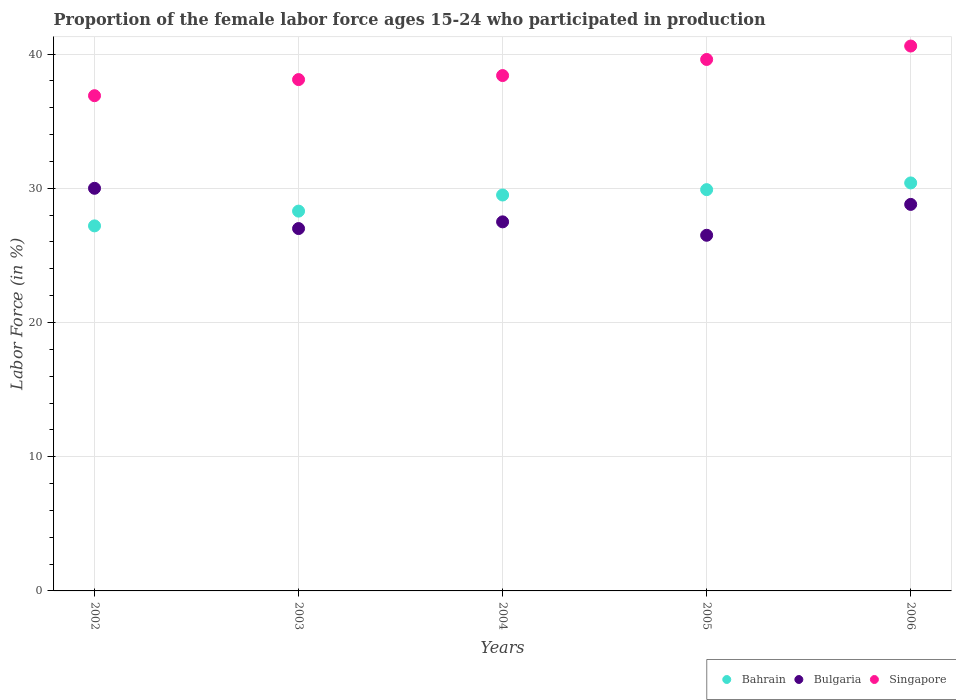Is the number of dotlines equal to the number of legend labels?
Offer a terse response. Yes. What is the proportion of the female labor force who participated in production in Singapore in 2004?
Your response must be concise. 38.4. What is the total proportion of the female labor force who participated in production in Bahrain in the graph?
Your answer should be compact. 145.3. What is the difference between the proportion of the female labor force who participated in production in Bulgaria in 2002 and that in 2005?
Offer a terse response. 3.5. What is the difference between the proportion of the female labor force who participated in production in Bulgaria in 2004 and the proportion of the female labor force who participated in production in Singapore in 2005?
Your answer should be very brief. -12.1. What is the average proportion of the female labor force who participated in production in Bahrain per year?
Keep it short and to the point. 29.06. In the year 2004, what is the difference between the proportion of the female labor force who participated in production in Bahrain and proportion of the female labor force who participated in production in Singapore?
Your answer should be compact. -8.9. What is the ratio of the proportion of the female labor force who participated in production in Bahrain in 2005 to that in 2006?
Provide a succinct answer. 0.98. Is the proportion of the female labor force who participated in production in Bulgaria in 2003 less than that in 2005?
Your answer should be very brief. No. Is the difference between the proportion of the female labor force who participated in production in Bahrain in 2002 and 2006 greater than the difference between the proportion of the female labor force who participated in production in Singapore in 2002 and 2006?
Make the answer very short. Yes. What is the difference between the highest and the second highest proportion of the female labor force who participated in production in Bahrain?
Provide a succinct answer. 0.5. What is the difference between the highest and the lowest proportion of the female labor force who participated in production in Bahrain?
Your answer should be compact. 3.2. In how many years, is the proportion of the female labor force who participated in production in Bahrain greater than the average proportion of the female labor force who participated in production in Bahrain taken over all years?
Offer a very short reply. 3. Is it the case that in every year, the sum of the proportion of the female labor force who participated in production in Bahrain and proportion of the female labor force who participated in production in Bulgaria  is greater than the proportion of the female labor force who participated in production in Singapore?
Your answer should be very brief. Yes. Does the proportion of the female labor force who participated in production in Singapore monotonically increase over the years?
Offer a terse response. Yes. How many years are there in the graph?
Your response must be concise. 5. Are the values on the major ticks of Y-axis written in scientific E-notation?
Offer a terse response. No. Does the graph contain any zero values?
Your answer should be compact. No. Where does the legend appear in the graph?
Provide a short and direct response. Bottom right. What is the title of the graph?
Provide a succinct answer. Proportion of the female labor force ages 15-24 who participated in production. Does "Suriname" appear as one of the legend labels in the graph?
Your answer should be compact. No. What is the label or title of the X-axis?
Ensure brevity in your answer.  Years. What is the Labor Force (in %) of Bahrain in 2002?
Provide a short and direct response. 27.2. What is the Labor Force (in %) of Singapore in 2002?
Your answer should be very brief. 36.9. What is the Labor Force (in %) of Bahrain in 2003?
Offer a very short reply. 28.3. What is the Labor Force (in %) of Bulgaria in 2003?
Provide a succinct answer. 27. What is the Labor Force (in %) of Singapore in 2003?
Your answer should be very brief. 38.1. What is the Labor Force (in %) in Bahrain in 2004?
Make the answer very short. 29.5. What is the Labor Force (in %) in Bulgaria in 2004?
Your answer should be very brief. 27.5. What is the Labor Force (in %) of Singapore in 2004?
Give a very brief answer. 38.4. What is the Labor Force (in %) in Bahrain in 2005?
Provide a short and direct response. 29.9. What is the Labor Force (in %) in Bulgaria in 2005?
Ensure brevity in your answer.  26.5. What is the Labor Force (in %) in Singapore in 2005?
Offer a terse response. 39.6. What is the Labor Force (in %) in Bahrain in 2006?
Your answer should be very brief. 30.4. What is the Labor Force (in %) in Bulgaria in 2006?
Provide a short and direct response. 28.8. What is the Labor Force (in %) in Singapore in 2006?
Keep it short and to the point. 40.6. Across all years, what is the maximum Labor Force (in %) in Bahrain?
Make the answer very short. 30.4. Across all years, what is the maximum Labor Force (in %) in Bulgaria?
Offer a terse response. 30. Across all years, what is the maximum Labor Force (in %) of Singapore?
Your answer should be very brief. 40.6. Across all years, what is the minimum Labor Force (in %) of Bahrain?
Make the answer very short. 27.2. Across all years, what is the minimum Labor Force (in %) of Singapore?
Offer a very short reply. 36.9. What is the total Labor Force (in %) of Bahrain in the graph?
Offer a terse response. 145.3. What is the total Labor Force (in %) in Bulgaria in the graph?
Offer a terse response. 139.8. What is the total Labor Force (in %) of Singapore in the graph?
Your response must be concise. 193.6. What is the difference between the Labor Force (in %) of Bahrain in 2002 and that in 2003?
Your response must be concise. -1.1. What is the difference between the Labor Force (in %) of Singapore in 2002 and that in 2003?
Give a very brief answer. -1.2. What is the difference between the Labor Force (in %) of Bahrain in 2002 and that in 2004?
Offer a very short reply. -2.3. What is the difference between the Labor Force (in %) in Bulgaria in 2002 and that in 2004?
Offer a terse response. 2.5. What is the difference between the Labor Force (in %) of Singapore in 2002 and that in 2004?
Offer a terse response. -1.5. What is the difference between the Labor Force (in %) in Bahrain in 2002 and that in 2005?
Give a very brief answer. -2.7. What is the difference between the Labor Force (in %) of Bulgaria in 2002 and that in 2005?
Give a very brief answer. 3.5. What is the difference between the Labor Force (in %) in Bulgaria in 2002 and that in 2006?
Make the answer very short. 1.2. What is the difference between the Labor Force (in %) in Bulgaria in 2003 and that in 2004?
Keep it short and to the point. -0.5. What is the difference between the Labor Force (in %) in Bahrain in 2003 and that in 2005?
Offer a very short reply. -1.6. What is the difference between the Labor Force (in %) of Bahrain in 2003 and that in 2006?
Ensure brevity in your answer.  -2.1. What is the difference between the Labor Force (in %) of Bulgaria in 2003 and that in 2006?
Make the answer very short. -1.8. What is the difference between the Labor Force (in %) of Singapore in 2003 and that in 2006?
Your answer should be very brief. -2.5. What is the difference between the Labor Force (in %) in Bahrain in 2004 and that in 2005?
Provide a short and direct response. -0.4. What is the difference between the Labor Force (in %) in Singapore in 2004 and that in 2005?
Offer a very short reply. -1.2. What is the difference between the Labor Force (in %) in Bulgaria in 2004 and that in 2006?
Make the answer very short. -1.3. What is the difference between the Labor Force (in %) of Singapore in 2004 and that in 2006?
Give a very brief answer. -2.2. What is the difference between the Labor Force (in %) in Bahrain in 2005 and that in 2006?
Ensure brevity in your answer.  -0.5. What is the difference between the Labor Force (in %) of Bahrain in 2002 and the Labor Force (in %) of Bulgaria in 2004?
Your answer should be compact. -0.3. What is the difference between the Labor Force (in %) in Bahrain in 2002 and the Labor Force (in %) in Singapore in 2004?
Ensure brevity in your answer.  -11.2. What is the difference between the Labor Force (in %) of Bahrain in 2002 and the Labor Force (in %) of Bulgaria in 2005?
Give a very brief answer. 0.7. What is the difference between the Labor Force (in %) of Bahrain in 2002 and the Labor Force (in %) of Singapore in 2005?
Offer a terse response. -12.4. What is the difference between the Labor Force (in %) of Bulgaria in 2002 and the Labor Force (in %) of Singapore in 2006?
Your response must be concise. -10.6. What is the difference between the Labor Force (in %) of Bahrain in 2003 and the Labor Force (in %) of Bulgaria in 2004?
Offer a very short reply. 0.8. What is the difference between the Labor Force (in %) in Bulgaria in 2003 and the Labor Force (in %) in Singapore in 2006?
Your answer should be compact. -13.6. What is the difference between the Labor Force (in %) in Bahrain in 2004 and the Labor Force (in %) in Bulgaria in 2006?
Your response must be concise. 0.7. What is the difference between the Labor Force (in %) in Bahrain in 2005 and the Labor Force (in %) in Singapore in 2006?
Ensure brevity in your answer.  -10.7. What is the difference between the Labor Force (in %) of Bulgaria in 2005 and the Labor Force (in %) of Singapore in 2006?
Your answer should be compact. -14.1. What is the average Labor Force (in %) of Bahrain per year?
Provide a succinct answer. 29.06. What is the average Labor Force (in %) in Bulgaria per year?
Offer a very short reply. 27.96. What is the average Labor Force (in %) of Singapore per year?
Make the answer very short. 38.72. In the year 2002, what is the difference between the Labor Force (in %) in Bahrain and Labor Force (in %) in Singapore?
Your answer should be very brief. -9.7. In the year 2003, what is the difference between the Labor Force (in %) in Bahrain and Labor Force (in %) in Bulgaria?
Your answer should be very brief. 1.3. In the year 2004, what is the difference between the Labor Force (in %) of Bahrain and Labor Force (in %) of Bulgaria?
Your answer should be very brief. 2. In the year 2004, what is the difference between the Labor Force (in %) of Bulgaria and Labor Force (in %) of Singapore?
Provide a succinct answer. -10.9. In the year 2005, what is the difference between the Labor Force (in %) of Bahrain and Labor Force (in %) of Singapore?
Give a very brief answer. -9.7. In the year 2006, what is the difference between the Labor Force (in %) of Bulgaria and Labor Force (in %) of Singapore?
Give a very brief answer. -11.8. What is the ratio of the Labor Force (in %) of Bahrain in 2002 to that in 2003?
Offer a terse response. 0.96. What is the ratio of the Labor Force (in %) in Bulgaria in 2002 to that in 2003?
Your answer should be very brief. 1.11. What is the ratio of the Labor Force (in %) of Singapore in 2002 to that in 2003?
Your response must be concise. 0.97. What is the ratio of the Labor Force (in %) of Bahrain in 2002 to that in 2004?
Offer a very short reply. 0.92. What is the ratio of the Labor Force (in %) of Singapore in 2002 to that in 2004?
Your response must be concise. 0.96. What is the ratio of the Labor Force (in %) in Bahrain in 2002 to that in 2005?
Make the answer very short. 0.91. What is the ratio of the Labor Force (in %) in Bulgaria in 2002 to that in 2005?
Your answer should be very brief. 1.13. What is the ratio of the Labor Force (in %) in Singapore in 2002 to that in 2005?
Your answer should be very brief. 0.93. What is the ratio of the Labor Force (in %) of Bahrain in 2002 to that in 2006?
Provide a short and direct response. 0.89. What is the ratio of the Labor Force (in %) in Bulgaria in 2002 to that in 2006?
Offer a terse response. 1.04. What is the ratio of the Labor Force (in %) in Singapore in 2002 to that in 2006?
Provide a succinct answer. 0.91. What is the ratio of the Labor Force (in %) of Bahrain in 2003 to that in 2004?
Give a very brief answer. 0.96. What is the ratio of the Labor Force (in %) in Bulgaria in 2003 to that in 2004?
Your answer should be very brief. 0.98. What is the ratio of the Labor Force (in %) in Singapore in 2003 to that in 2004?
Keep it short and to the point. 0.99. What is the ratio of the Labor Force (in %) in Bahrain in 2003 to that in 2005?
Offer a terse response. 0.95. What is the ratio of the Labor Force (in %) in Bulgaria in 2003 to that in 2005?
Offer a very short reply. 1.02. What is the ratio of the Labor Force (in %) of Singapore in 2003 to that in 2005?
Keep it short and to the point. 0.96. What is the ratio of the Labor Force (in %) of Bahrain in 2003 to that in 2006?
Ensure brevity in your answer.  0.93. What is the ratio of the Labor Force (in %) of Singapore in 2003 to that in 2006?
Ensure brevity in your answer.  0.94. What is the ratio of the Labor Force (in %) of Bahrain in 2004 to that in 2005?
Provide a short and direct response. 0.99. What is the ratio of the Labor Force (in %) of Bulgaria in 2004 to that in 2005?
Keep it short and to the point. 1.04. What is the ratio of the Labor Force (in %) in Singapore in 2004 to that in 2005?
Ensure brevity in your answer.  0.97. What is the ratio of the Labor Force (in %) in Bahrain in 2004 to that in 2006?
Make the answer very short. 0.97. What is the ratio of the Labor Force (in %) in Bulgaria in 2004 to that in 2006?
Provide a short and direct response. 0.95. What is the ratio of the Labor Force (in %) in Singapore in 2004 to that in 2006?
Make the answer very short. 0.95. What is the ratio of the Labor Force (in %) in Bahrain in 2005 to that in 2006?
Provide a succinct answer. 0.98. What is the ratio of the Labor Force (in %) in Bulgaria in 2005 to that in 2006?
Keep it short and to the point. 0.92. What is the ratio of the Labor Force (in %) of Singapore in 2005 to that in 2006?
Keep it short and to the point. 0.98. What is the difference between the highest and the second highest Labor Force (in %) in Bahrain?
Offer a very short reply. 0.5. What is the difference between the highest and the second highest Labor Force (in %) in Bulgaria?
Your answer should be compact. 1.2. What is the difference between the highest and the lowest Labor Force (in %) in Bahrain?
Ensure brevity in your answer.  3.2. 